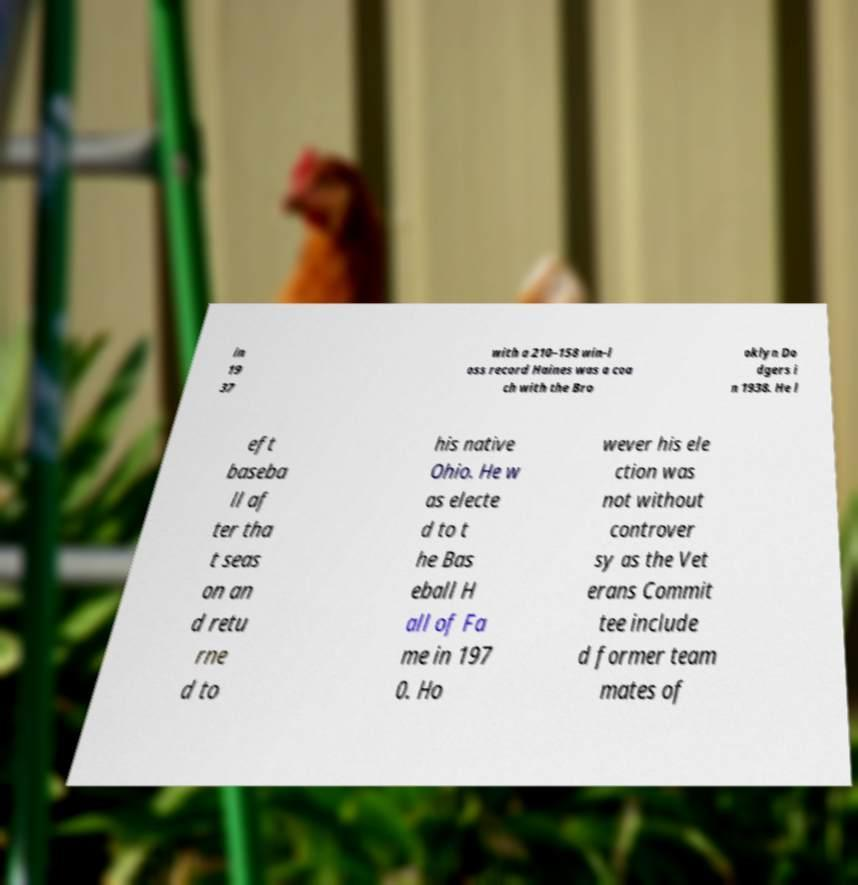Could you assist in decoding the text presented in this image and type it out clearly? in 19 37 with a 210–158 win-l oss record Haines was a coa ch with the Bro oklyn Do dgers i n 1938. He l eft baseba ll af ter tha t seas on an d retu rne d to his native Ohio. He w as electe d to t he Bas eball H all of Fa me in 197 0. Ho wever his ele ction was not without controver sy as the Vet erans Commit tee include d former team mates of 